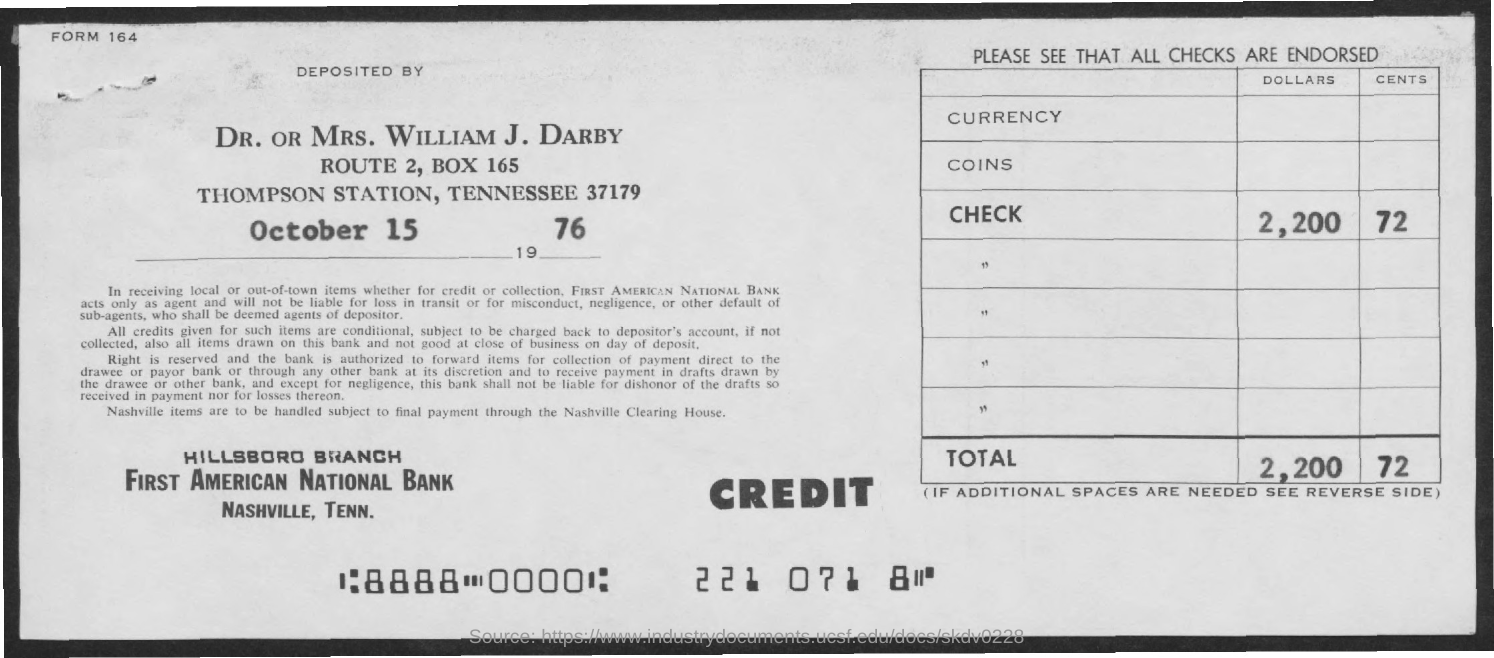The amount is deposited on which date?
Provide a short and direct response. October 15 1976. 